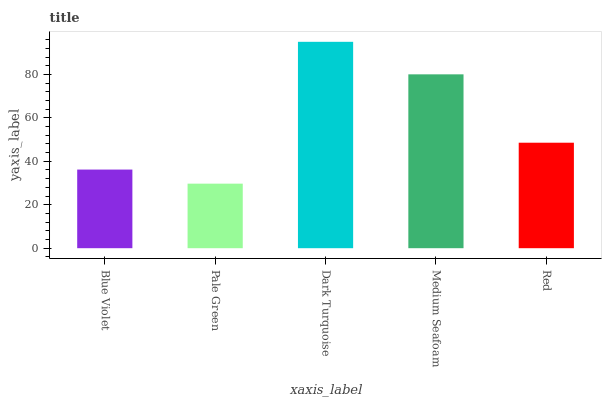Is Pale Green the minimum?
Answer yes or no. Yes. Is Dark Turquoise the maximum?
Answer yes or no. Yes. Is Dark Turquoise the minimum?
Answer yes or no. No. Is Pale Green the maximum?
Answer yes or no. No. Is Dark Turquoise greater than Pale Green?
Answer yes or no. Yes. Is Pale Green less than Dark Turquoise?
Answer yes or no. Yes. Is Pale Green greater than Dark Turquoise?
Answer yes or no. No. Is Dark Turquoise less than Pale Green?
Answer yes or no. No. Is Red the high median?
Answer yes or no. Yes. Is Red the low median?
Answer yes or no. Yes. Is Blue Violet the high median?
Answer yes or no. No. Is Medium Seafoam the low median?
Answer yes or no. No. 